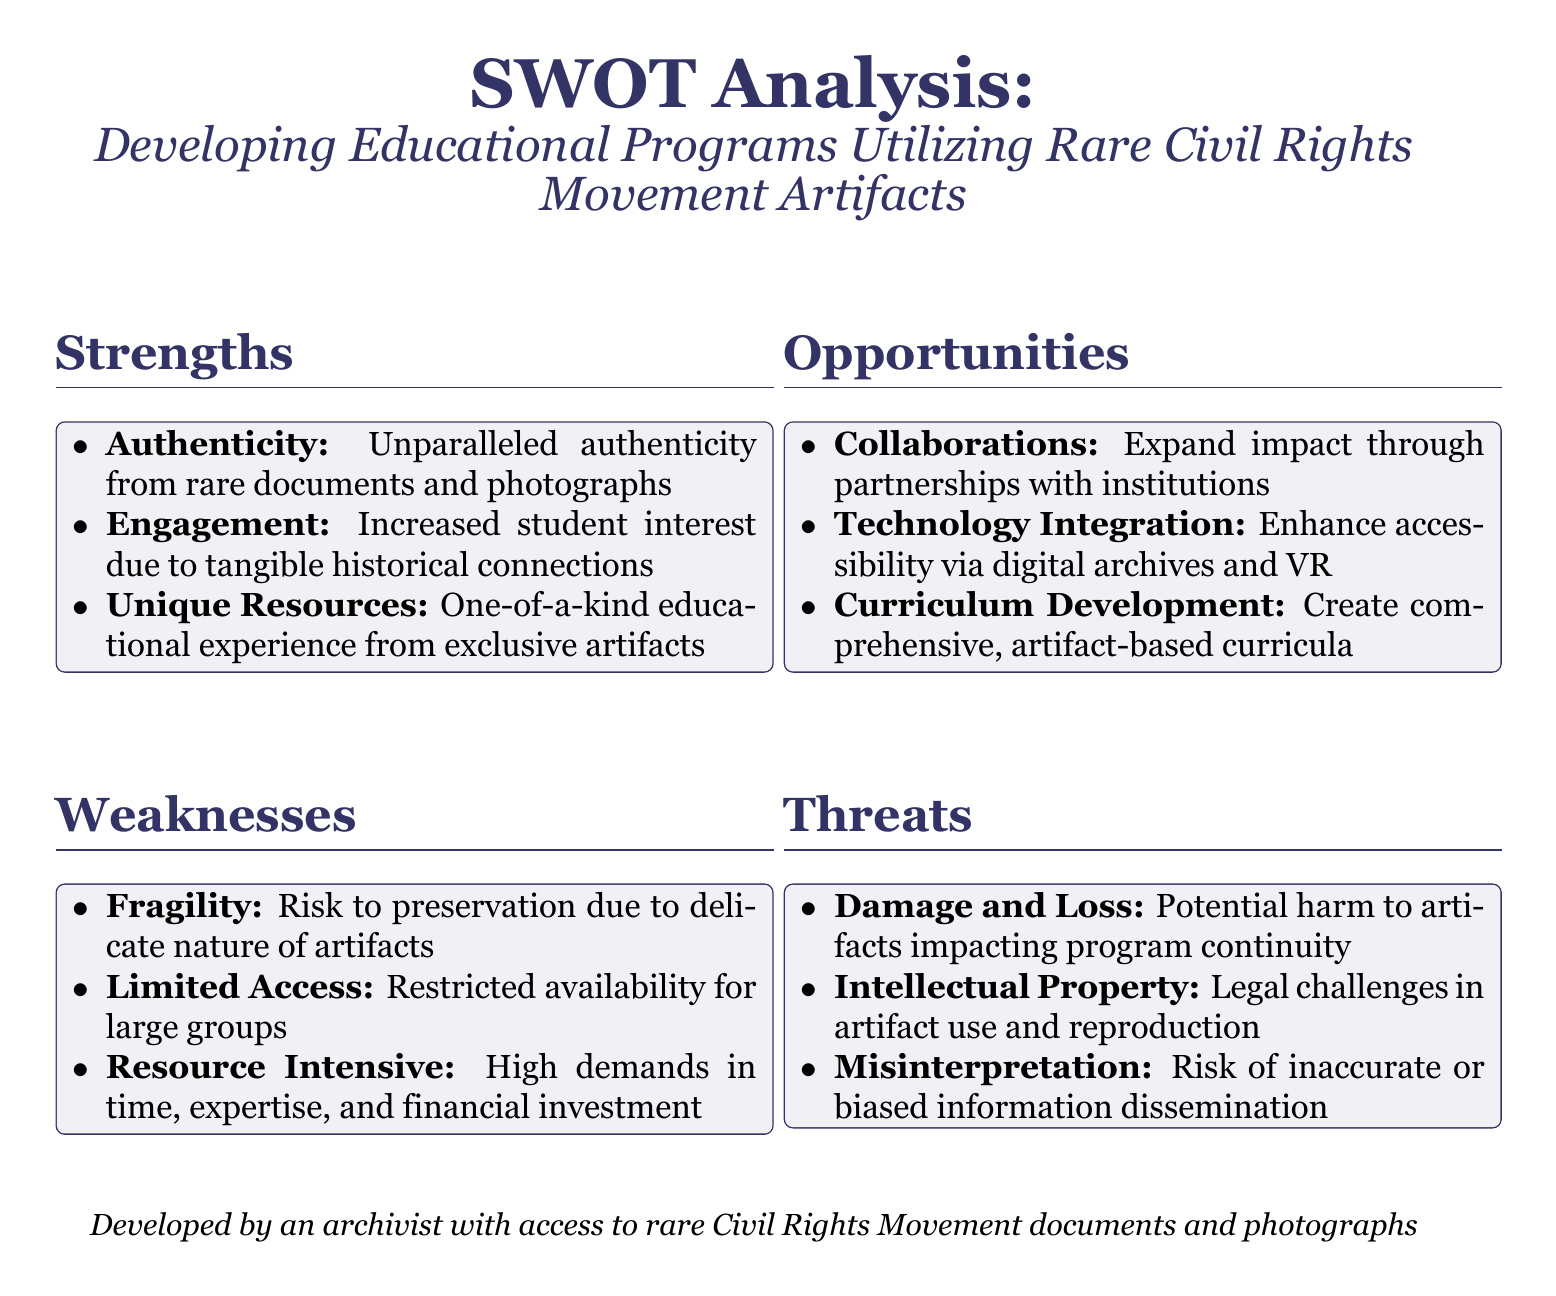What are the three strengths listed? The three strengths mentioned in the SWOT analysis are "Authenticity," "Engagement," and "Unique Resources."
Answer: Authenticity, Engagement, Unique Resources What opportunity involves partnership? The opportunity related to partnership is "Collaborations" aimed at expanding impact through working with institutions.
Answer: Collaborations What is a threat to artifacts mentioned? One of the threats listed is "Damage and Loss," which refers to potential harm to artifacts affecting program continuity.
Answer: Damage and Loss How many weaknesses are identified? The document outlines three weaknesses in total, namely "Fragility," "Limited Access," and "Resource Intensive."
Answer: Three What technology is suggested for enhancing accessibility? The suggested technology for enhancing accessibility includes "digital archives and VR."
Answer: digital archives and VR What does the document title refer to? The title of the document refers to a "SWOT Analysis" focused on "Developing Educational Programs Utilizing Rare Civil Rights Movement Artifacts."
Answer: SWOT Analysis: Developing Educational Programs Utilizing Rare Civil Rights Movement Artifacts Which font is used in the document? The font used in the document is specified as "Georgia."
Answer: Georgia 